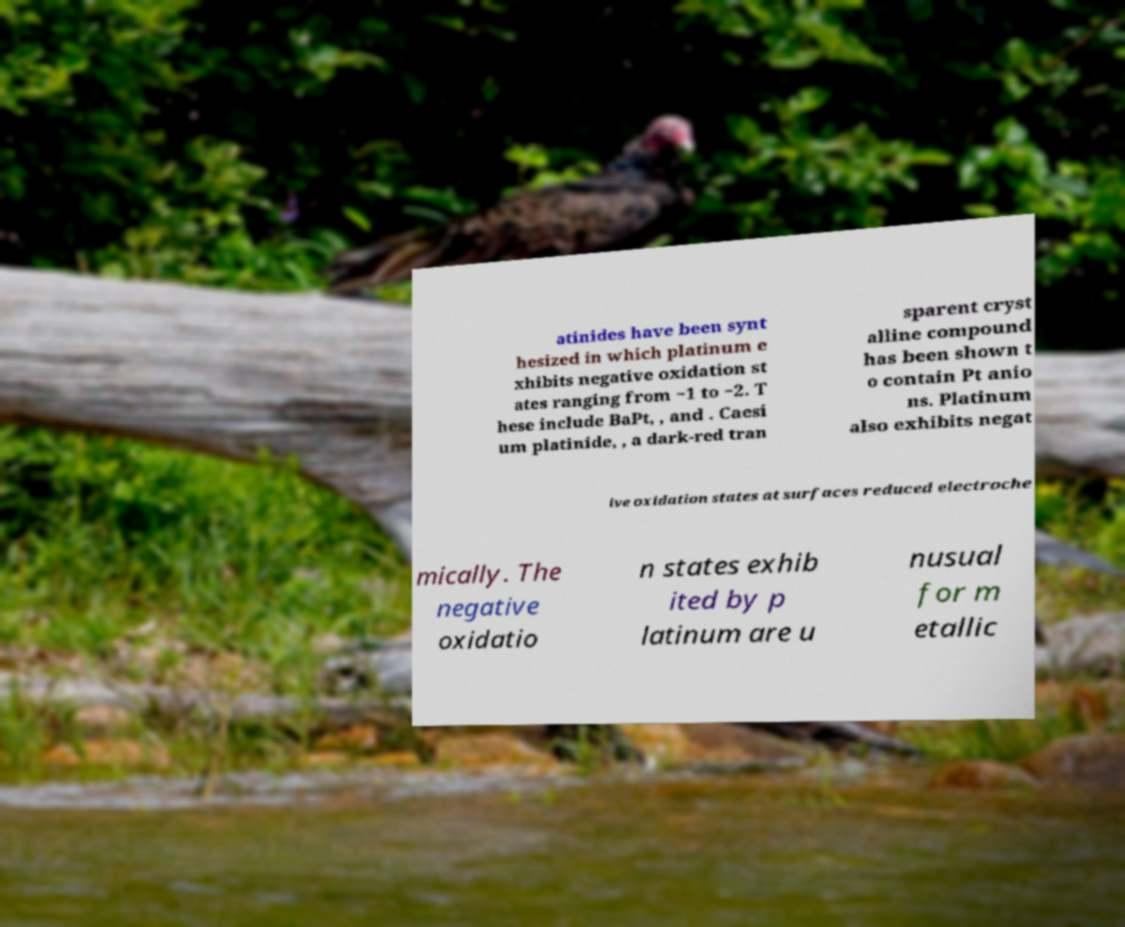Could you assist in decoding the text presented in this image and type it out clearly? atinides have been synt hesized in which platinum e xhibits negative oxidation st ates ranging from −1 to −2. T hese include BaPt, , and . Caesi um platinide, , a dark-red tran sparent cryst alline compound has been shown t o contain Pt anio ns. Platinum also exhibits negat ive oxidation states at surfaces reduced electroche mically. The negative oxidatio n states exhib ited by p latinum are u nusual for m etallic 